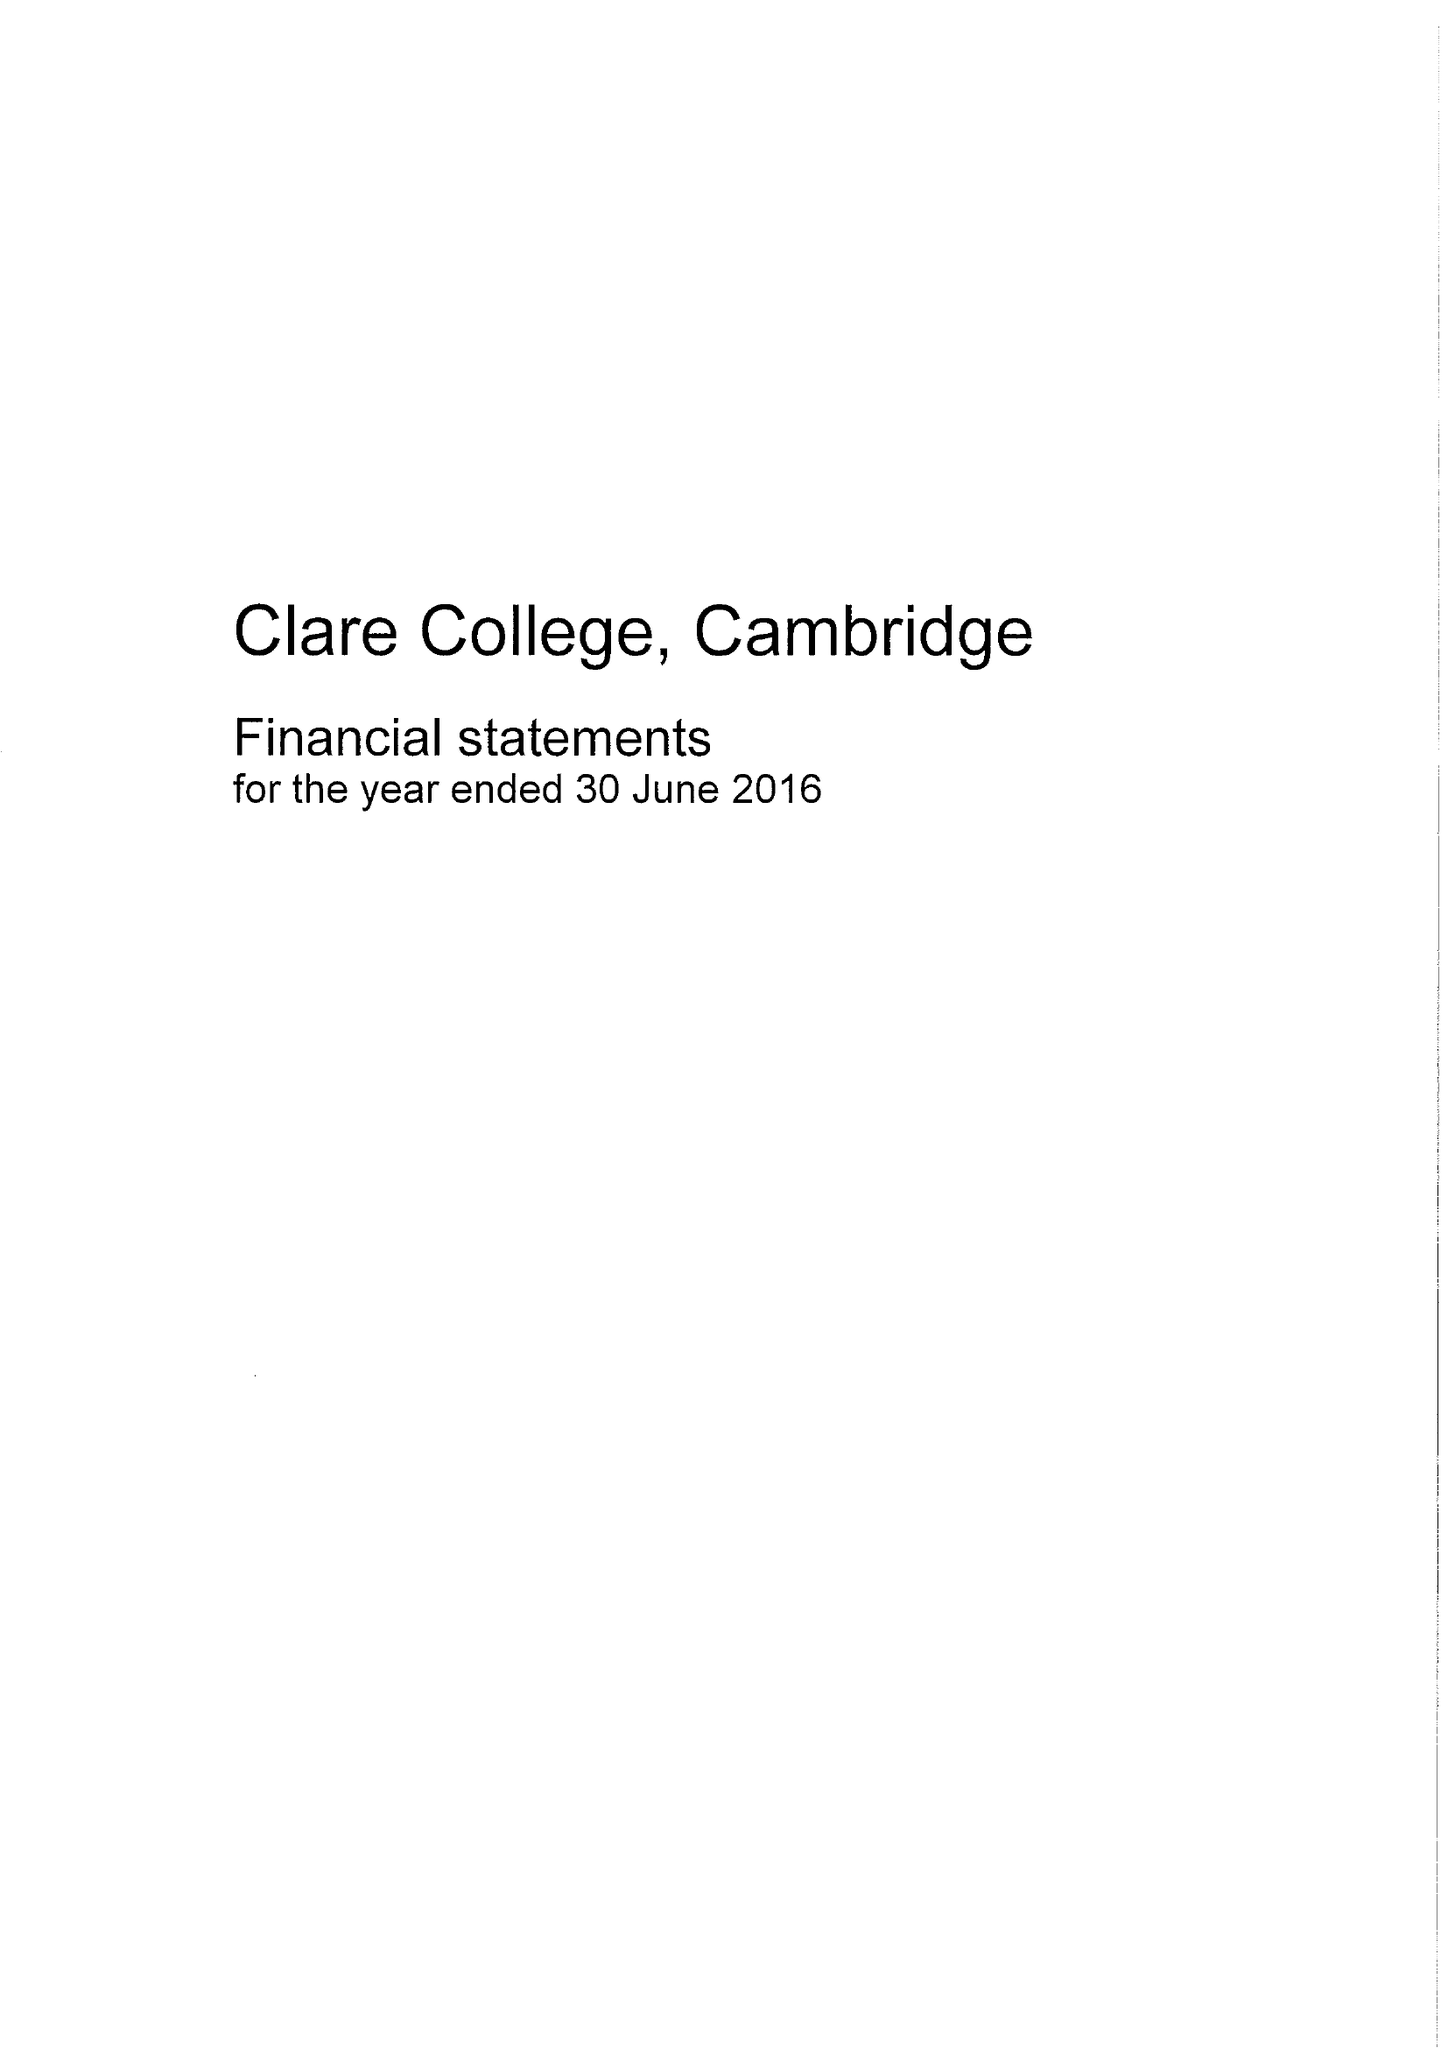What is the value for the charity_name?
Answer the question using a single word or phrase. Clare College Cambridge 